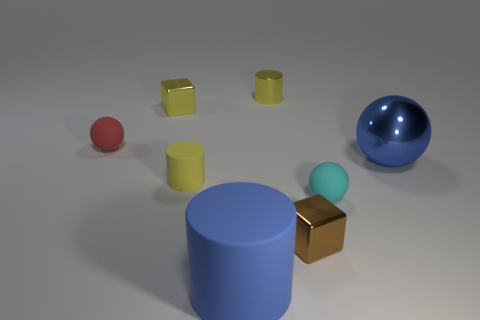Add 1 small rubber spheres. How many objects exist? 9 Subtract all blocks. How many objects are left? 6 Subtract 0 blue blocks. How many objects are left? 8 Subtract all red rubber spheres. Subtract all large blue balls. How many objects are left? 6 Add 6 big blue cylinders. How many big blue cylinders are left? 7 Add 1 tiny brown metal blocks. How many tiny brown metal blocks exist? 2 